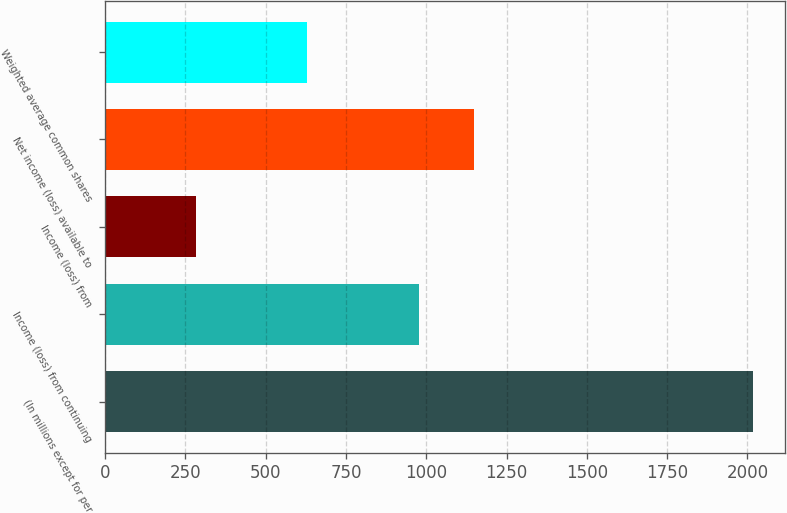Convert chart to OTSL. <chart><loc_0><loc_0><loc_500><loc_500><bar_chart><fcel>(In millions except for per<fcel>Income (loss) from continuing<fcel>Income (loss) from<fcel>Net income (loss) available to<fcel>Weighted average common shares<nl><fcel>2016<fcel>976.2<fcel>283<fcel>1149.5<fcel>629.6<nl></chart> 